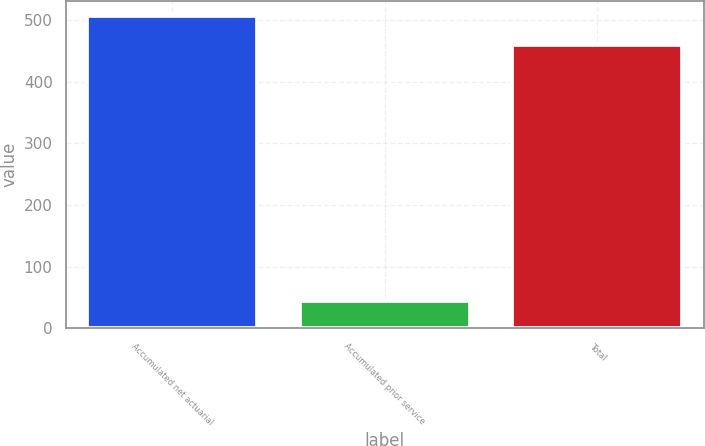<chart> <loc_0><loc_0><loc_500><loc_500><bar_chart><fcel>Accumulated net actuarial<fcel>Accumulated prior service<fcel>Total<nl><fcel>506<fcel>45<fcel>460<nl></chart> 